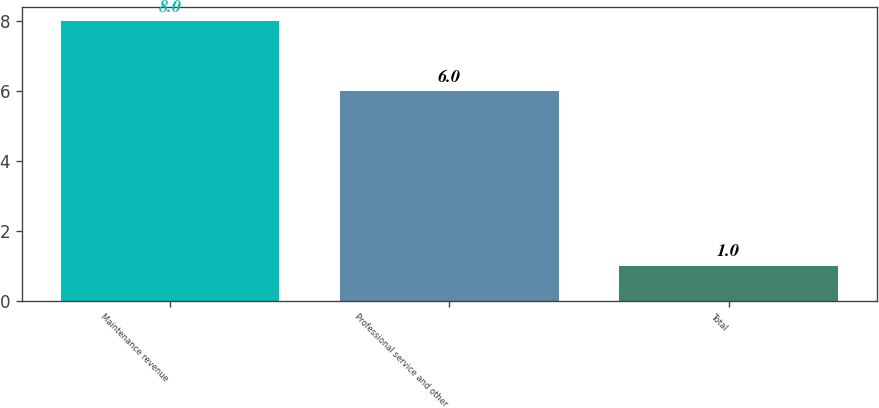Convert chart. <chart><loc_0><loc_0><loc_500><loc_500><bar_chart><fcel>Maintenance revenue<fcel>Professional service and other<fcel>Total<nl><fcel>8<fcel>6<fcel>1<nl></chart> 